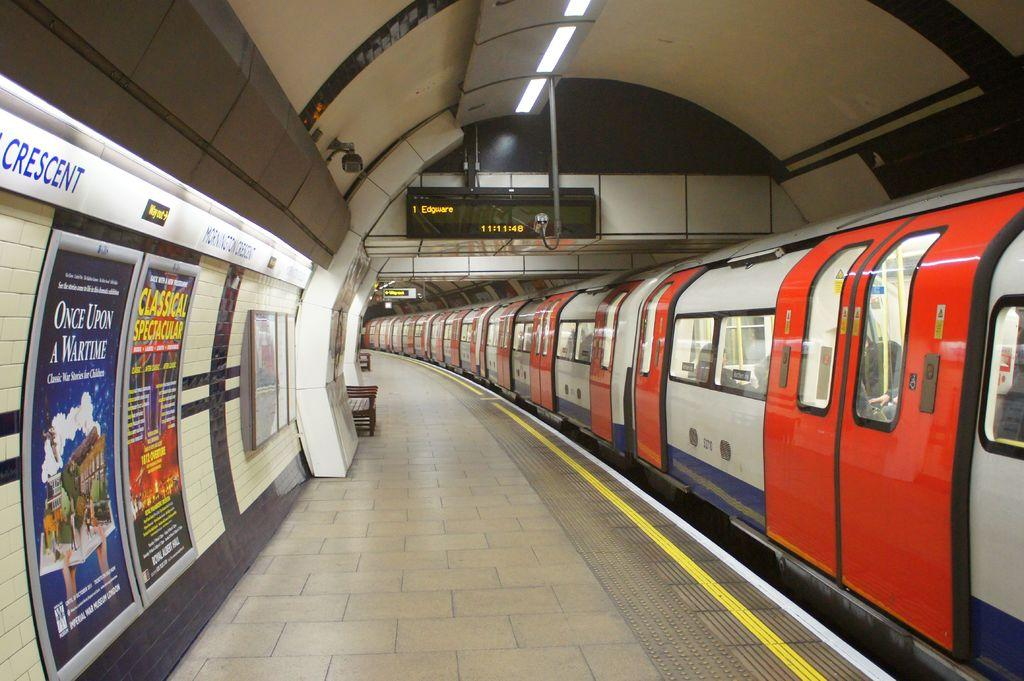<image>
Provide a brief description of the given image. An ad for Once Upon a Wartime is on the wall of a subway station. 